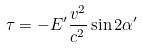<formula> <loc_0><loc_0><loc_500><loc_500>\tau = - E ^ { \prime } \frac { v ^ { 2 } } { c ^ { 2 } } \sin 2 \alpha ^ { \prime }</formula> 